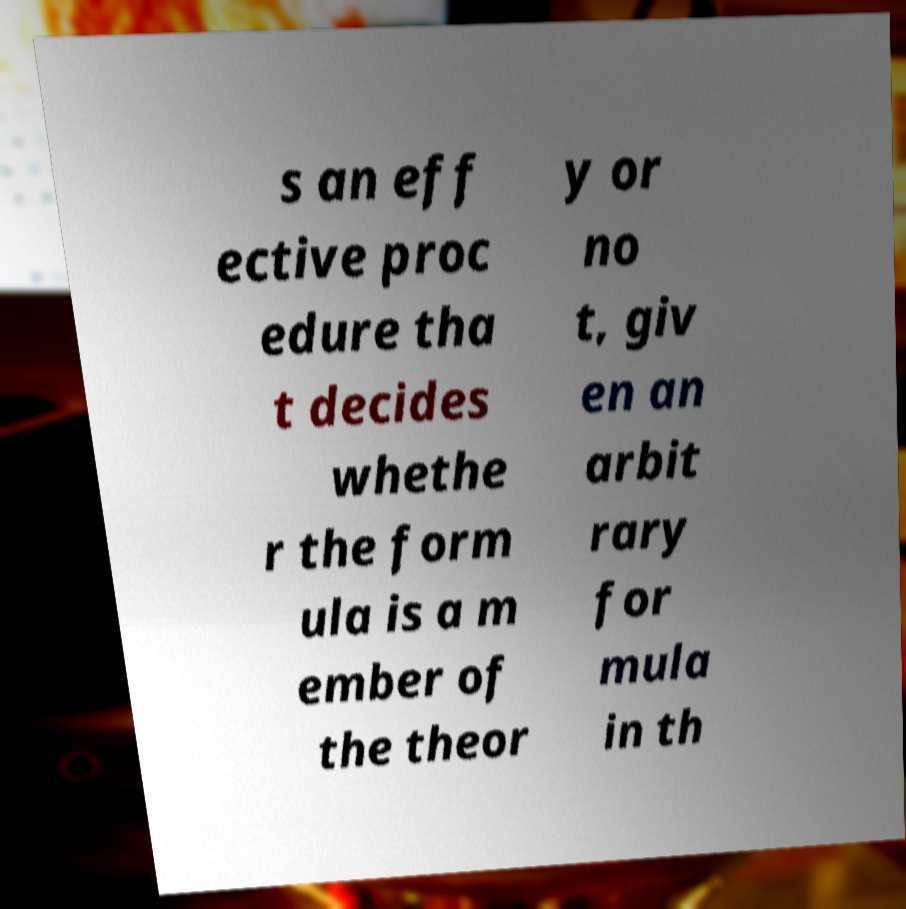Can you accurately transcribe the text from the provided image for me? s an eff ective proc edure tha t decides whethe r the form ula is a m ember of the theor y or no t, giv en an arbit rary for mula in th 